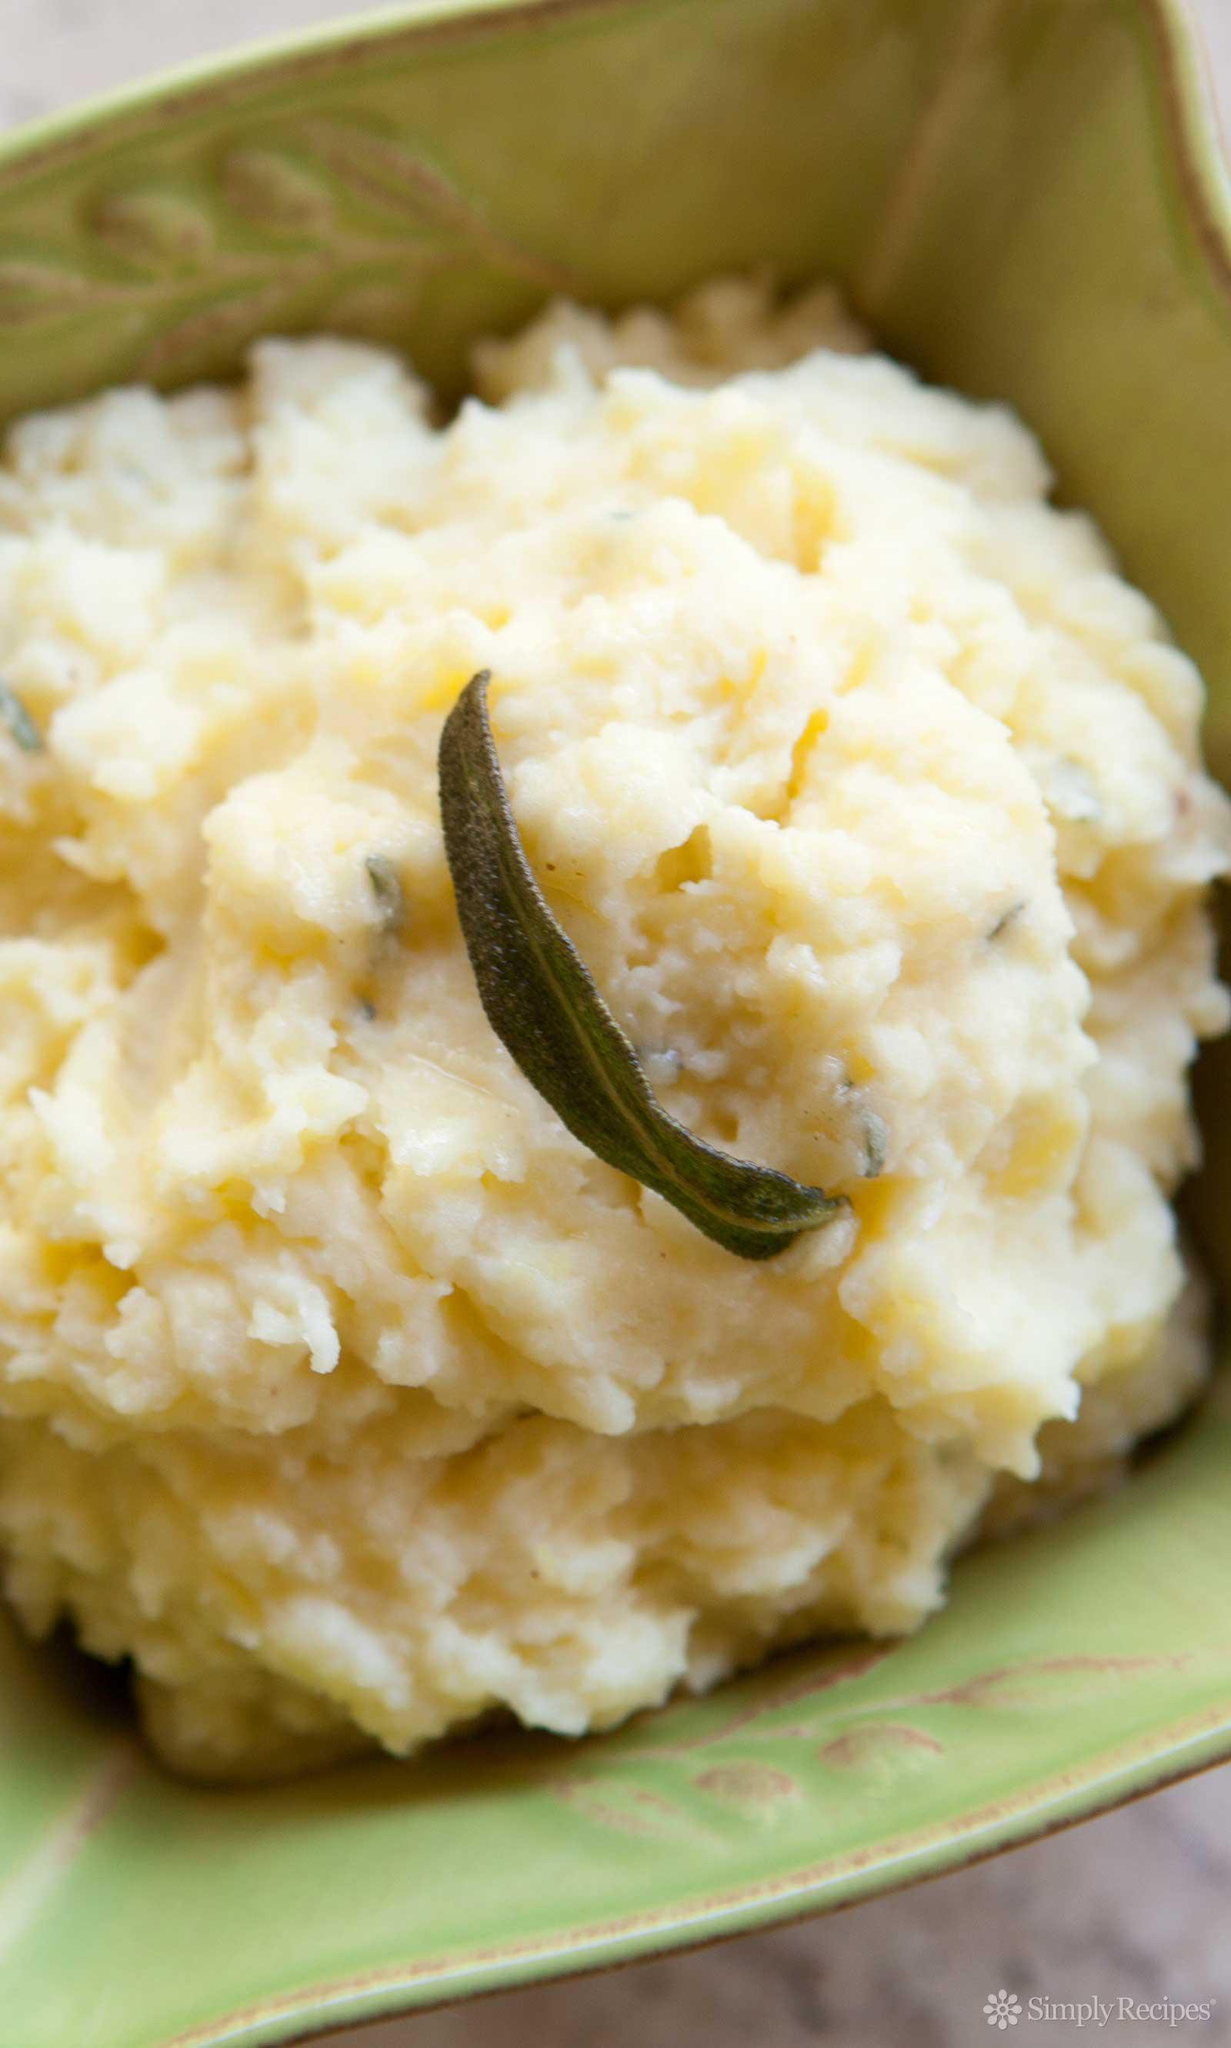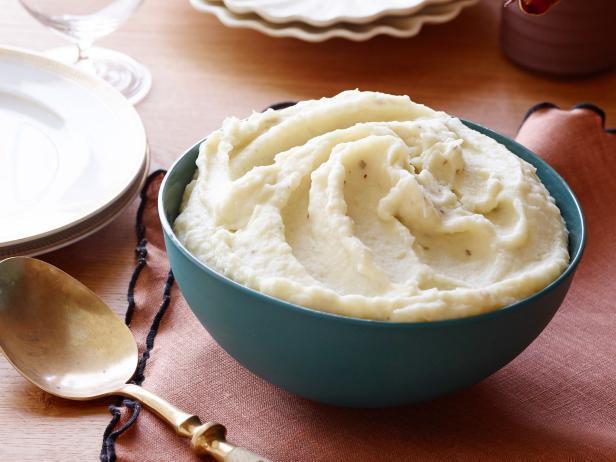The first image is the image on the left, the second image is the image on the right. Given the left and right images, does the statement "the image on the left has potatoes in a square bowl" hold true? Answer yes or no. Yes. 